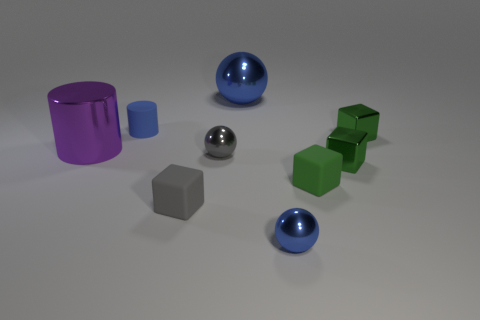There is a tiny thing that is the same color as the small matte cylinder; what is it made of?
Keep it short and to the point. Metal. Are there any other things that are the same size as the gray metallic sphere?
Keep it short and to the point. Yes. Are there any tiny green shiny things in front of the small blue ball?
Provide a short and direct response. No. What is the shape of the small gray shiny object?
Your answer should be compact. Sphere. How many objects are large things that are behind the tiny matte cylinder or small blue rubber cylinders?
Your response must be concise. 2. How many other objects are the same color as the large cylinder?
Your answer should be compact. 0. There is a big sphere; is its color the same as the small ball that is to the right of the large blue metallic object?
Ensure brevity in your answer.  Yes. There is another small rubber thing that is the same shape as the gray rubber thing; what color is it?
Offer a very short reply. Green. Is the material of the big blue object the same as the block to the left of the large blue metallic sphere?
Offer a terse response. No. The small rubber cylinder is what color?
Ensure brevity in your answer.  Blue. 